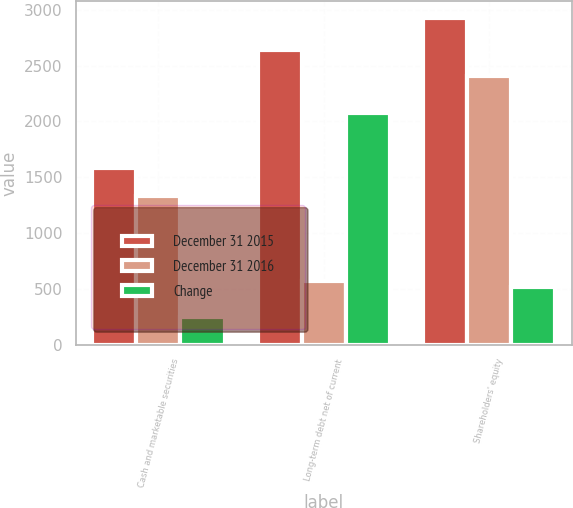Convert chart. <chart><loc_0><loc_0><loc_500><loc_500><stacked_bar_chart><ecel><fcel>Cash and marketable securities<fcel>Long-term debt net of current<fcel>Shareholders' equity<nl><fcel>December 31 2015<fcel>1580<fcel>2645<fcel>2931<nl><fcel>December 31 2016<fcel>1328<fcel>569<fcel>2411<nl><fcel>Change<fcel>252<fcel>2076<fcel>520<nl></chart> 